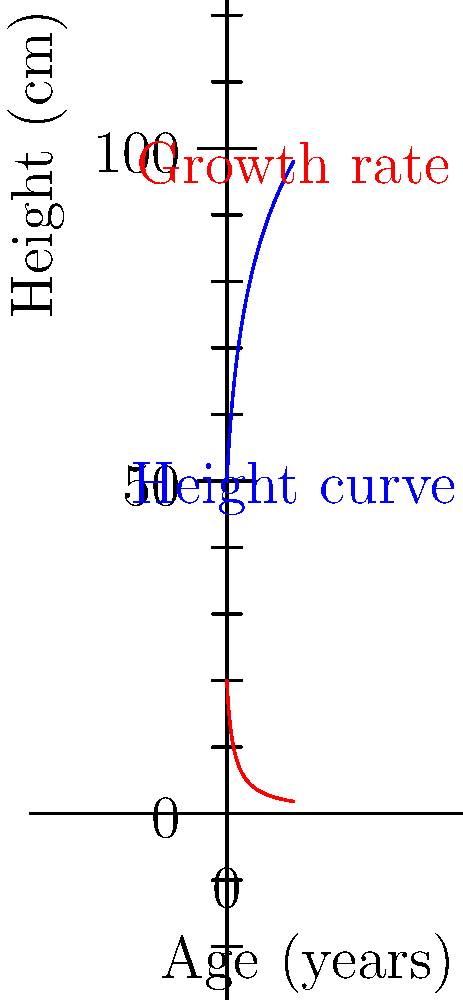The blue curve represents the height of a child over time, while the red curve shows the growth rate. At what age (in years) does the child's growth rate slow down to 5 cm per year? To solve this problem, we need to follow these steps:

1) The red curve represents the growth rate, which is given by the function $g(x) = \frac{20}{x+1}$, where $x$ is the age in years.

2) We want to find when this rate equals 5 cm per year. So we need to solve the equation:

   $\frac{20}{x+1} = 5$

3) Multiply both sides by $(x+1)$:

   $20 = 5(x+1)$

4) Distribute on the right side:

   $20 = 5x + 5$

5) Subtract 5 from both sides:

   $15 = 5x$

6) Divide both sides by 5:

   $3 = x$

Therefore, the growth rate slows to 5 cm per year when the child is 3 years old.
Answer: 3 years 